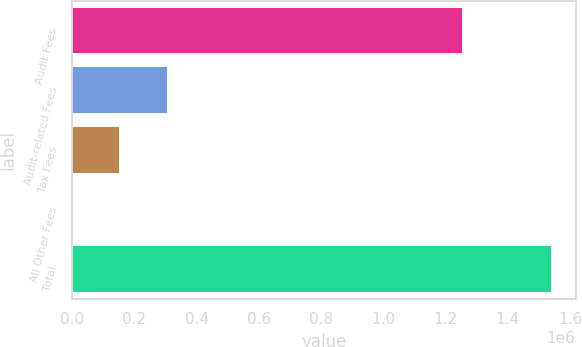Convert chart. <chart><loc_0><loc_0><loc_500><loc_500><bar_chart><fcel>Audit Fees<fcel>Audit-related Fees<fcel>Tax Fees<fcel>All Other Fees<fcel>Total<nl><fcel>1.255e+06<fcel>309235<fcel>155235<fcel>1235<fcel>1.54124e+06<nl></chart> 